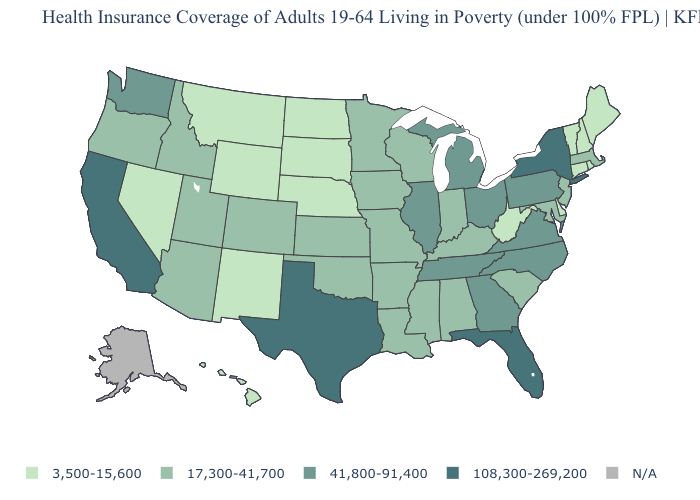What is the value of Arkansas?
Short answer required. 17,300-41,700. Name the states that have a value in the range 108,300-269,200?
Short answer required. California, Florida, New York, Texas. Which states have the highest value in the USA?
Be succinct. California, Florida, New York, Texas. What is the value of Maryland?
Answer briefly. 17,300-41,700. Which states have the lowest value in the USA?
Write a very short answer. Connecticut, Delaware, Hawaii, Maine, Montana, Nebraska, Nevada, New Hampshire, New Mexico, North Dakota, Rhode Island, South Dakota, Vermont, West Virginia, Wyoming. What is the lowest value in states that border North Carolina?
Keep it brief. 17,300-41,700. What is the value of Rhode Island?
Quick response, please. 3,500-15,600. What is the value of Georgia?
Concise answer only. 41,800-91,400. What is the highest value in the South ?
Short answer required. 108,300-269,200. Among the states that border Missouri , does Illinois have the highest value?
Quick response, please. Yes. Does Minnesota have the lowest value in the USA?
Concise answer only. No. Among the states that border Rhode Island , does Connecticut have the lowest value?
Write a very short answer. Yes. Name the states that have a value in the range 108,300-269,200?
Concise answer only. California, Florida, New York, Texas. Does California have the highest value in the USA?
Short answer required. Yes. 